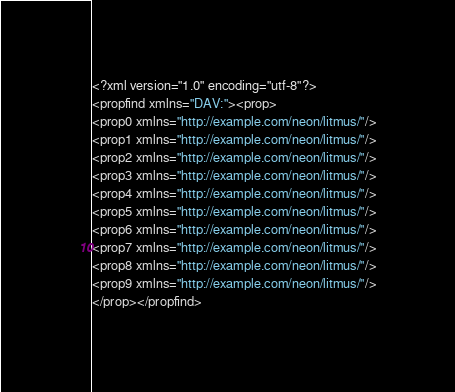Convert code to text. <code><loc_0><loc_0><loc_500><loc_500><_XML_><?xml version="1.0" encoding="utf-8"?>
<propfind xmlns="DAV:"><prop>
<prop0 xmlns="http://example.com/neon/litmus/"/>
<prop1 xmlns="http://example.com/neon/litmus/"/>
<prop2 xmlns="http://example.com/neon/litmus/"/>
<prop3 xmlns="http://example.com/neon/litmus/"/>
<prop4 xmlns="http://example.com/neon/litmus/"/>
<prop5 xmlns="http://example.com/neon/litmus/"/>
<prop6 xmlns="http://example.com/neon/litmus/"/>
<prop7 xmlns="http://example.com/neon/litmus/"/>
<prop8 xmlns="http://example.com/neon/litmus/"/>
<prop9 xmlns="http://example.com/neon/litmus/"/>
</prop></propfind>
</code> 